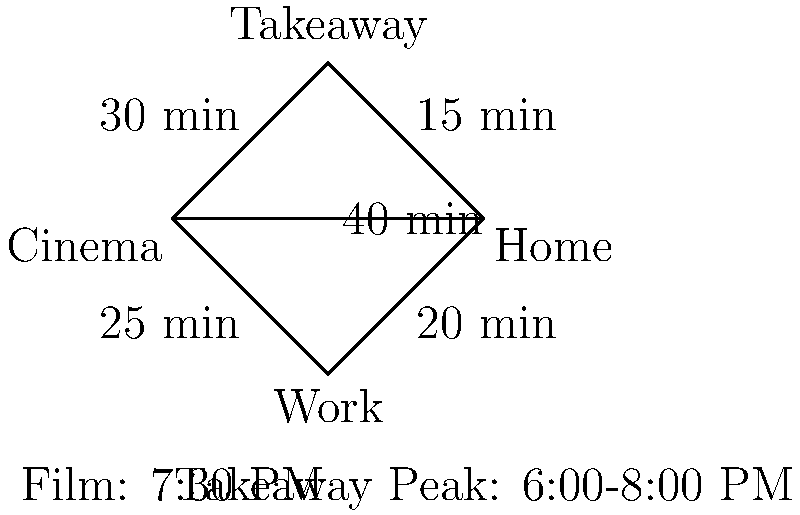Based on the flow chart depicting film screening times and peak hours for Chinese takeaway orders, what is the latest time you should leave work to pick up a takeaway order and make it to the 7:30 PM film screening, assuming you want to arrive at the cinema 10 minutes before the film starts? To solve this problem, we need to work backwards from the film start time:

1. The film starts at 7:30 PM.
2. We want to arrive 10 minutes before the film, so we need to be at the cinema by 7:20 PM.
3. From the flow chart, we can see that it takes 30 minutes to get from the takeaway to the cinema.
4. This means we need to leave the takeaway by 6:50 PM at the latest.
5. The chart shows it takes 15 minutes to get from work to the takeaway.
6. Therefore, we need to leave work by 6:35 PM at the latest.

It's worth noting that the takeaway peak hours are from 6:00-8:00 PM, so leaving work at 6:35 PM puts us right in the middle of the peak time. This might mean longer wait times at the takeaway, but the calculation doesn't account for this potential delay.
Answer: 6:35 PM 